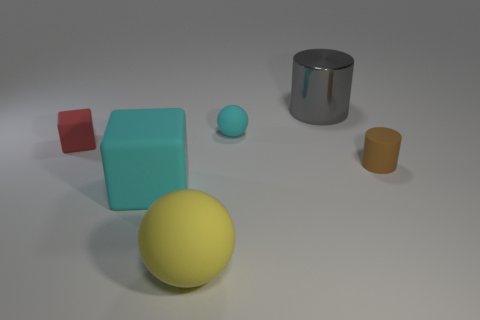What time of day does the lighting in the image suggest? The image seems to be using neutral, diffused lighting which doesn't provide clear indicators of a natural time of day, as it is characteristic of a controlled, indoor setup. In a natural setting, the soft shadows and lack of warmth in the lighting could be perceived as overcast daylight conditions, indicative of either mid-morning or mid-afternoon in indirect sunlight. 